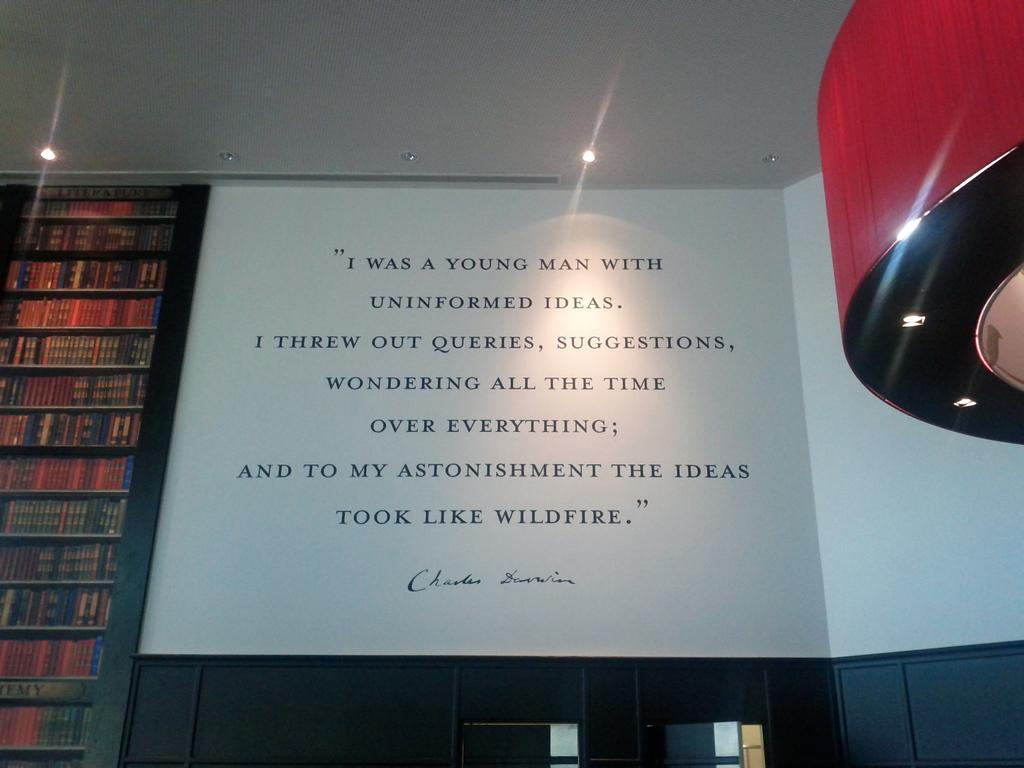<image>
Present a compact description of the photo's key features. A Charles Darwin quote is displayed on a wall next to shelves of books 